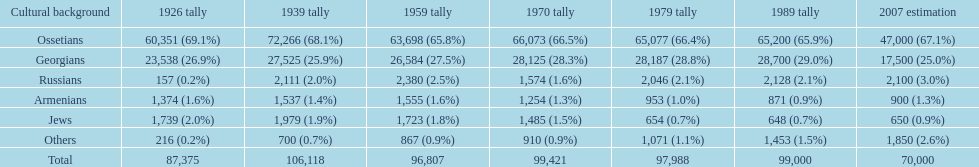Who is previous of the russians based on the list? Georgians. 